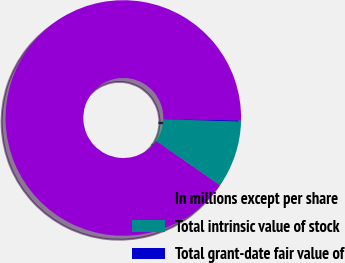<chart> <loc_0><loc_0><loc_500><loc_500><pie_chart><fcel>In millions except per share<fcel>Total intrinsic value of stock<fcel>Total grant-date fair value of<nl><fcel>90.68%<fcel>9.19%<fcel>0.14%<nl></chart> 